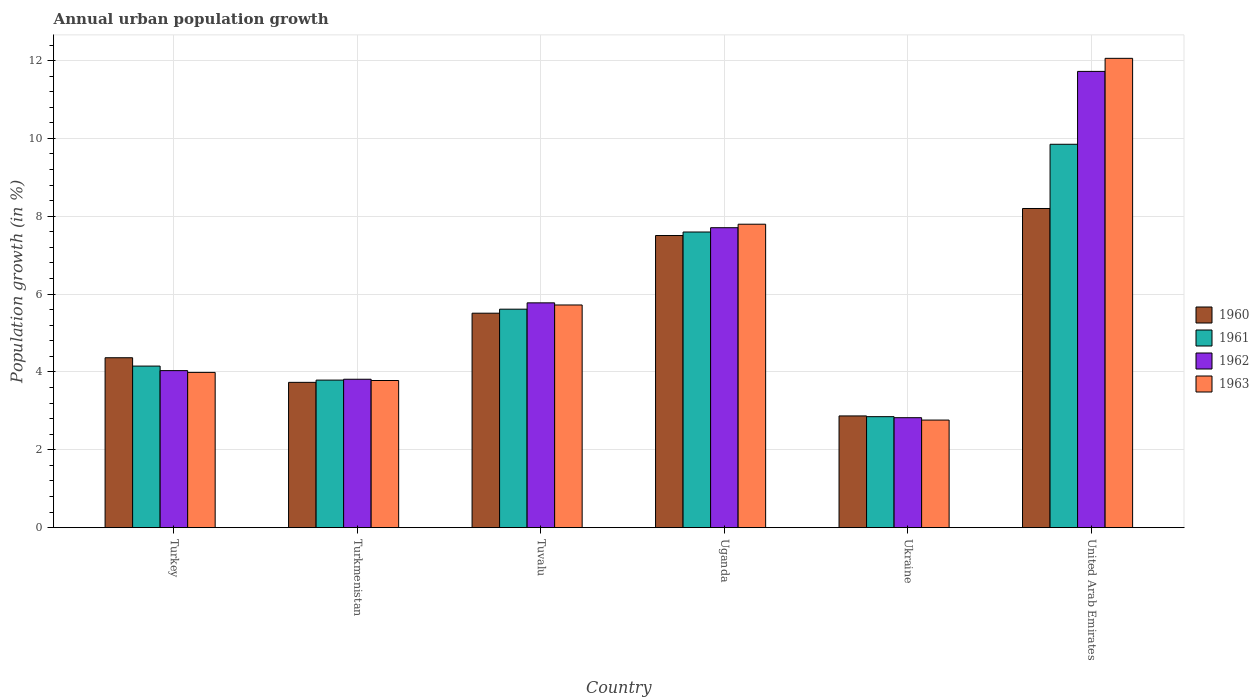How many different coloured bars are there?
Your answer should be compact. 4. How many groups of bars are there?
Your answer should be very brief. 6. How many bars are there on the 6th tick from the left?
Keep it short and to the point. 4. How many bars are there on the 3rd tick from the right?
Your answer should be very brief. 4. What is the label of the 2nd group of bars from the left?
Offer a terse response. Turkmenistan. In how many cases, is the number of bars for a given country not equal to the number of legend labels?
Your response must be concise. 0. What is the percentage of urban population growth in 1963 in United Arab Emirates?
Provide a succinct answer. 12.06. Across all countries, what is the maximum percentage of urban population growth in 1963?
Make the answer very short. 12.06. Across all countries, what is the minimum percentage of urban population growth in 1963?
Your answer should be very brief. 2.76. In which country was the percentage of urban population growth in 1961 maximum?
Give a very brief answer. United Arab Emirates. In which country was the percentage of urban population growth in 1961 minimum?
Provide a short and direct response. Ukraine. What is the total percentage of urban population growth in 1960 in the graph?
Your answer should be compact. 32.18. What is the difference between the percentage of urban population growth in 1961 in Turkey and that in Ukraine?
Offer a terse response. 1.3. What is the difference between the percentage of urban population growth in 1961 in Turkmenistan and the percentage of urban population growth in 1962 in Turkey?
Keep it short and to the point. -0.24. What is the average percentage of urban population growth in 1961 per country?
Your answer should be compact. 5.64. What is the difference between the percentage of urban population growth of/in 1960 and percentage of urban population growth of/in 1961 in Tuvalu?
Your response must be concise. -0.1. What is the ratio of the percentage of urban population growth in 1960 in Tuvalu to that in Uganda?
Offer a terse response. 0.73. Is the percentage of urban population growth in 1962 in Turkey less than that in Tuvalu?
Your response must be concise. Yes. Is the difference between the percentage of urban population growth in 1960 in Turkmenistan and Uganda greater than the difference between the percentage of urban population growth in 1961 in Turkmenistan and Uganda?
Offer a terse response. Yes. What is the difference between the highest and the second highest percentage of urban population growth in 1960?
Give a very brief answer. 2.69. What is the difference between the highest and the lowest percentage of urban population growth in 1961?
Your response must be concise. 7. Is it the case that in every country, the sum of the percentage of urban population growth in 1961 and percentage of urban population growth in 1963 is greater than the sum of percentage of urban population growth in 1960 and percentage of urban population growth in 1962?
Offer a very short reply. No. What does the 1st bar from the right in Turkmenistan represents?
Keep it short and to the point. 1963. How many bars are there?
Your answer should be compact. 24. Are all the bars in the graph horizontal?
Give a very brief answer. No. What is the title of the graph?
Offer a very short reply. Annual urban population growth. Does "1998" appear as one of the legend labels in the graph?
Provide a short and direct response. No. What is the label or title of the Y-axis?
Ensure brevity in your answer.  Population growth (in %). What is the Population growth (in %) of 1960 in Turkey?
Give a very brief answer. 4.37. What is the Population growth (in %) of 1961 in Turkey?
Provide a short and direct response. 4.15. What is the Population growth (in %) of 1962 in Turkey?
Offer a very short reply. 4.03. What is the Population growth (in %) in 1963 in Turkey?
Provide a succinct answer. 3.99. What is the Population growth (in %) of 1960 in Turkmenistan?
Provide a short and direct response. 3.73. What is the Population growth (in %) in 1961 in Turkmenistan?
Keep it short and to the point. 3.79. What is the Population growth (in %) in 1962 in Turkmenistan?
Offer a terse response. 3.81. What is the Population growth (in %) in 1963 in Turkmenistan?
Offer a very short reply. 3.78. What is the Population growth (in %) in 1960 in Tuvalu?
Give a very brief answer. 5.51. What is the Population growth (in %) in 1961 in Tuvalu?
Your answer should be compact. 5.61. What is the Population growth (in %) of 1962 in Tuvalu?
Offer a very short reply. 5.78. What is the Population growth (in %) of 1963 in Tuvalu?
Make the answer very short. 5.72. What is the Population growth (in %) in 1960 in Uganda?
Keep it short and to the point. 7.51. What is the Population growth (in %) in 1961 in Uganda?
Provide a succinct answer. 7.6. What is the Population growth (in %) in 1962 in Uganda?
Ensure brevity in your answer.  7.71. What is the Population growth (in %) of 1963 in Uganda?
Offer a terse response. 7.8. What is the Population growth (in %) of 1960 in Ukraine?
Keep it short and to the point. 2.87. What is the Population growth (in %) in 1961 in Ukraine?
Keep it short and to the point. 2.85. What is the Population growth (in %) of 1962 in Ukraine?
Offer a very short reply. 2.82. What is the Population growth (in %) in 1963 in Ukraine?
Make the answer very short. 2.76. What is the Population growth (in %) in 1960 in United Arab Emirates?
Provide a short and direct response. 8.2. What is the Population growth (in %) in 1961 in United Arab Emirates?
Ensure brevity in your answer.  9.85. What is the Population growth (in %) of 1962 in United Arab Emirates?
Offer a very short reply. 11.72. What is the Population growth (in %) of 1963 in United Arab Emirates?
Your response must be concise. 12.06. Across all countries, what is the maximum Population growth (in %) of 1960?
Your answer should be very brief. 8.2. Across all countries, what is the maximum Population growth (in %) in 1961?
Your answer should be very brief. 9.85. Across all countries, what is the maximum Population growth (in %) in 1962?
Keep it short and to the point. 11.72. Across all countries, what is the maximum Population growth (in %) in 1963?
Provide a succinct answer. 12.06. Across all countries, what is the minimum Population growth (in %) in 1960?
Your answer should be very brief. 2.87. Across all countries, what is the minimum Population growth (in %) of 1961?
Offer a terse response. 2.85. Across all countries, what is the minimum Population growth (in %) in 1962?
Your response must be concise. 2.82. Across all countries, what is the minimum Population growth (in %) of 1963?
Provide a succinct answer. 2.76. What is the total Population growth (in %) in 1960 in the graph?
Offer a very short reply. 32.18. What is the total Population growth (in %) of 1961 in the graph?
Give a very brief answer. 33.85. What is the total Population growth (in %) of 1962 in the graph?
Give a very brief answer. 35.88. What is the total Population growth (in %) in 1963 in the graph?
Provide a succinct answer. 36.11. What is the difference between the Population growth (in %) in 1960 in Turkey and that in Turkmenistan?
Offer a very short reply. 0.63. What is the difference between the Population growth (in %) of 1961 in Turkey and that in Turkmenistan?
Provide a succinct answer. 0.36. What is the difference between the Population growth (in %) of 1962 in Turkey and that in Turkmenistan?
Your answer should be compact. 0.22. What is the difference between the Population growth (in %) of 1963 in Turkey and that in Turkmenistan?
Provide a short and direct response. 0.21. What is the difference between the Population growth (in %) in 1960 in Turkey and that in Tuvalu?
Your answer should be compact. -1.14. What is the difference between the Population growth (in %) of 1961 in Turkey and that in Tuvalu?
Your answer should be very brief. -1.46. What is the difference between the Population growth (in %) of 1962 in Turkey and that in Tuvalu?
Give a very brief answer. -1.74. What is the difference between the Population growth (in %) in 1963 in Turkey and that in Tuvalu?
Give a very brief answer. -1.73. What is the difference between the Population growth (in %) of 1960 in Turkey and that in Uganda?
Give a very brief answer. -3.14. What is the difference between the Population growth (in %) in 1961 in Turkey and that in Uganda?
Give a very brief answer. -3.44. What is the difference between the Population growth (in %) of 1962 in Turkey and that in Uganda?
Make the answer very short. -3.67. What is the difference between the Population growth (in %) of 1963 in Turkey and that in Uganda?
Your response must be concise. -3.81. What is the difference between the Population growth (in %) of 1960 in Turkey and that in Ukraine?
Keep it short and to the point. 1.49. What is the difference between the Population growth (in %) in 1961 in Turkey and that in Ukraine?
Ensure brevity in your answer.  1.3. What is the difference between the Population growth (in %) of 1962 in Turkey and that in Ukraine?
Your answer should be very brief. 1.21. What is the difference between the Population growth (in %) of 1963 in Turkey and that in Ukraine?
Offer a terse response. 1.22. What is the difference between the Population growth (in %) of 1960 in Turkey and that in United Arab Emirates?
Give a very brief answer. -3.83. What is the difference between the Population growth (in %) in 1961 in Turkey and that in United Arab Emirates?
Your answer should be compact. -5.7. What is the difference between the Population growth (in %) in 1962 in Turkey and that in United Arab Emirates?
Your answer should be compact. -7.69. What is the difference between the Population growth (in %) of 1963 in Turkey and that in United Arab Emirates?
Offer a very short reply. -8.07. What is the difference between the Population growth (in %) of 1960 in Turkmenistan and that in Tuvalu?
Provide a succinct answer. -1.78. What is the difference between the Population growth (in %) in 1961 in Turkmenistan and that in Tuvalu?
Keep it short and to the point. -1.82. What is the difference between the Population growth (in %) in 1962 in Turkmenistan and that in Tuvalu?
Provide a short and direct response. -1.96. What is the difference between the Population growth (in %) in 1963 in Turkmenistan and that in Tuvalu?
Ensure brevity in your answer.  -1.94. What is the difference between the Population growth (in %) of 1960 in Turkmenistan and that in Uganda?
Provide a short and direct response. -3.77. What is the difference between the Population growth (in %) of 1961 in Turkmenistan and that in Uganda?
Offer a terse response. -3.8. What is the difference between the Population growth (in %) of 1962 in Turkmenistan and that in Uganda?
Offer a very short reply. -3.89. What is the difference between the Population growth (in %) in 1963 in Turkmenistan and that in Uganda?
Make the answer very short. -4.02. What is the difference between the Population growth (in %) in 1960 in Turkmenistan and that in Ukraine?
Keep it short and to the point. 0.86. What is the difference between the Population growth (in %) of 1961 in Turkmenistan and that in Ukraine?
Provide a succinct answer. 0.94. What is the difference between the Population growth (in %) of 1963 in Turkmenistan and that in Ukraine?
Keep it short and to the point. 1.02. What is the difference between the Population growth (in %) in 1960 in Turkmenistan and that in United Arab Emirates?
Your response must be concise. -4.47. What is the difference between the Population growth (in %) in 1961 in Turkmenistan and that in United Arab Emirates?
Keep it short and to the point. -6.06. What is the difference between the Population growth (in %) of 1962 in Turkmenistan and that in United Arab Emirates?
Offer a terse response. -7.91. What is the difference between the Population growth (in %) of 1963 in Turkmenistan and that in United Arab Emirates?
Ensure brevity in your answer.  -8.28. What is the difference between the Population growth (in %) in 1960 in Tuvalu and that in Uganda?
Your answer should be very brief. -2. What is the difference between the Population growth (in %) in 1961 in Tuvalu and that in Uganda?
Provide a succinct answer. -1.98. What is the difference between the Population growth (in %) in 1962 in Tuvalu and that in Uganda?
Provide a short and direct response. -1.93. What is the difference between the Population growth (in %) in 1963 in Tuvalu and that in Uganda?
Give a very brief answer. -2.08. What is the difference between the Population growth (in %) of 1960 in Tuvalu and that in Ukraine?
Ensure brevity in your answer.  2.64. What is the difference between the Population growth (in %) in 1961 in Tuvalu and that in Ukraine?
Ensure brevity in your answer.  2.76. What is the difference between the Population growth (in %) in 1962 in Tuvalu and that in Ukraine?
Ensure brevity in your answer.  2.95. What is the difference between the Population growth (in %) in 1963 in Tuvalu and that in Ukraine?
Make the answer very short. 2.96. What is the difference between the Population growth (in %) of 1960 in Tuvalu and that in United Arab Emirates?
Your answer should be very brief. -2.69. What is the difference between the Population growth (in %) in 1961 in Tuvalu and that in United Arab Emirates?
Provide a short and direct response. -4.24. What is the difference between the Population growth (in %) in 1962 in Tuvalu and that in United Arab Emirates?
Provide a short and direct response. -5.95. What is the difference between the Population growth (in %) of 1963 in Tuvalu and that in United Arab Emirates?
Keep it short and to the point. -6.34. What is the difference between the Population growth (in %) of 1960 in Uganda and that in Ukraine?
Offer a very short reply. 4.64. What is the difference between the Population growth (in %) of 1961 in Uganda and that in Ukraine?
Provide a succinct answer. 4.74. What is the difference between the Population growth (in %) of 1962 in Uganda and that in Ukraine?
Offer a very short reply. 4.88. What is the difference between the Population growth (in %) of 1963 in Uganda and that in Ukraine?
Your response must be concise. 5.03. What is the difference between the Population growth (in %) in 1960 in Uganda and that in United Arab Emirates?
Your response must be concise. -0.69. What is the difference between the Population growth (in %) in 1961 in Uganda and that in United Arab Emirates?
Offer a very short reply. -2.25. What is the difference between the Population growth (in %) in 1962 in Uganda and that in United Arab Emirates?
Provide a short and direct response. -4.02. What is the difference between the Population growth (in %) in 1963 in Uganda and that in United Arab Emirates?
Give a very brief answer. -4.26. What is the difference between the Population growth (in %) of 1960 in Ukraine and that in United Arab Emirates?
Provide a short and direct response. -5.33. What is the difference between the Population growth (in %) of 1961 in Ukraine and that in United Arab Emirates?
Provide a short and direct response. -7. What is the difference between the Population growth (in %) in 1962 in Ukraine and that in United Arab Emirates?
Provide a succinct answer. -8.9. What is the difference between the Population growth (in %) in 1963 in Ukraine and that in United Arab Emirates?
Provide a succinct answer. -9.29. What is the difference between the Population growth (in %) in 1960 in Turkey and the Population growth (in %) in 1961 in Turkmenistan?
Keep it short and to the point. 0.57. What is the difference between the Population growth (in %) of 1960 in Turkey and the Population growth (in %) of 1962 in Turkmenistan?
Give a very brief answer. 0.55. What is the difference between the Population growth (in %) in 1960 in Turkey and the Population growth (in %) in 1963 in Turkmenistan?
Ensure brevity in your answer.  0.58. What is the difference between the Population growth (in %) of 1961 in Turkey and the Population growth (in %) of 1962 in Turkmenistan?
Give a very brief answer. 0.34. What is the difference between the Population growth (in %) in 1961 in Turkey and the Population growth (in %) in 1963 in Turkmenistan?
Provide a succinct answer. 0.37. What is the difference between the Population growth (in %) of 1962 in Turkey and the Population growth (in %) of 1963 in Turkmenistan?
Give a very brief answer. 0.25. What is the difference between the Population growth (in %) in 1960 in Turkey and the Population growth (in %) in 1961 in Tuvalu?
Make the answer very short. -1.25. What is the difference between the Population growth (in %) in 1960 in Turkey and the Population growth (in %) in 1962 in Tuvalu?
Provide a succinct answer. -1.41. What is the difference between the Population growth (in %) of 1960 in Turkey and the Population growth (in %) of 1963 in Tuvalu?
Provide a succinct answer. -1.36. What is the difference between the Population growth (in %) in 1961 in Turkey and the Population growth (in %) in 1962 in Tuvalu?
Your answer should be compact. -1.62. What is the difference between the Population growth (in %) of 1961 in Turkey and the Population growth (in %) of 1963 in Tuvalu?
Offer a terse response. -1.57. What is the difference between the Population growth (in %) of 1962 in Turkey and the Population growth (in %) of 1963 in Tuvalu?
Offer a very short reply. -1.69. What is the difference between the Population growth (in %) in 1960 in Turkey and the Population growth (in %) in 1961 in Uganda?
Offer a very short reply. -3.23. What is the difference between the Population growth (in %) in 1960 in Turkey and the Population growth (in %) in 1962 in Uganda?
Give a very brief answer. -3.34. What is the difference between the Population growth (in %) in 1960 in Turkey and the Population growth (in %) in 1963 in Uganda?
Your answer should be compact. -3.43. What is the difference between the Population growth (in %) of 1961 in Turkey and the Population growth (in %) of 1962 in Uganda?
Make the answer very short. -3.56. What is the difference between the Population growth (in %) of 1961 in Turkey and the Population growth (in %) of 1963 in Uganda?
Your answer should be compact. -3.65. What is the difference between the Population growth (in %) of 1962 in Turkey and the Population growth (in %) of 1963 in Uganda?
Provide a short and direct response. -3.76. What is the difference between the Population growth (in %) of 1960 in Turkey and the Population growth (in %) of 1961 in Ukraine?
Ensure brevity in your answer.  1.51. What is the difference between the Population growth (in %) of 1960 in Turkey and the Population growth (in %) of 1962 in Ukraine?
Your answer should be compact. 1.54. What is the difference between the Population growth (in %) in 1960 in Turkey and the Population growth (in %) in 1963 in Ukraine?
Make the answer very short. 1.6. What is the difference between the Population growth (in %) in 1961 in Turkey and the Population growth (in %) in 1962 in Ukraine?
Provide a succinct answer. 1.33. What is the difference between the Population growth (in %) of 1961 in Turkey and the Population growth (in %) of 1963 in Ukraine?
Provide a short and direct response. 1.39. What is the difference between the Population growth (in %) in 1962 in Turkey and the Population growth (in %) in 1963 in Ukraine?
Offer a terse response. 1.27. What is the difference between the Population growth (in %) in 1960 in Turkey and the Population growth (in %) in 1961 in United Arab Emirates?
Your answer should be very brief. -5.48. What is the difference between the Population growth (in %) in 1960 in Turkey and the Population growth (in %) in 1962 in United Arab Emirates?
Your answer should be very brief. -7.36. What is the difference between the Population growth (in %) in 1960 in Turkey and the Population growth (in %) in 1963 in United Arab Emirates?
Your response must be concise. -7.69. What is the difference between the Population growth (in %) of 1961 in Turkey and the Population growth (in %) of 1962 in United Arab Emirates?
Keep it short and to the point. -7.57. What is the difference between the Population growth (in %) in 1961 in Turkey and the Population growth (in %) in 1963 in United Arab Emirates?
Give a very brief answer. -7.91. What is the difference between the Population growth (in %) in 1962 in Turkey and the Population growth (in %) in 1963 in United Arab Emirates?
Keep it short and to the point. -8.02. What is the difference between the Population growth (in %) in 1960 in Turkmenistan and the Population growth (in %) in 1961 in Tuvalu?
Your response must be concise. -1.88. What is the difference between the Population growth (in %) of 1960 in Turkmenistan and the Population growth (in %) of 1962 in Tuvalu?
Make the answer very short. -2.04. What is the difference between the Population growth (in %) in 1960 in Turkmenistan and the Population growth (in %) in 1963 in Tuvalu?
Provide a succinct answer. -1.99. What is the difference between the Population growth (in %) in 1961 in Turkmenistan and the Population growth (in %) in 1962 in Tuvalu?
Your answer should be compact. -1.98. What is the difference between the Population growth (in %) of 1961 in Turkmenistan and the Population growth (in %) of 1963 in Tuvalu?
Offer a terse response. -1.93. What is the difference between the Population growth (in %) in 1962 in Turkmenistan and the Population growth (in %) in 1963 in Tuvalu?
Offer a very short reply. -1.91. What is the difference between the Population growth (in %) of 1960 in Turkmenistan and the Population growth (in %) of 1961 in Uganda?
Keep it short and to the point. -3.86. What is the difference between the Population growth (in %) in 1960 in Turkmenistan and the Population growth (in %) in 1962 in Uganda?
Provide a short and direct response. -3.97. What is the difference between the Population growth (in %) of 1960 in Turkmenistan and the Population growth (in %) of 1963 in Uganda?
Ensure brevity in your answer.  -4.06. What is the difference between the Population growth (in %) of 1961 in Turkmenistan and the Population growth (in %) of 1962 in Uganda?
Your answer should be very brief. -3.92. What is the difference between the Population growth (in %) in 1961 in Turkmenistan and the Population growth (in %) in 1963 in Uganda?
Provide a succinct answer. -4.01. What is the difference between the Population growth (in %) in 1962 in Turkmenistan and the Population growth (in %) in 1963 in Uganda?
Your answer should be very brief. -3.98. What is the difference between the Population growth (in %) of 1960 in Turkmenistan and the Population growth (in %) of 1961 in Ukraine?
Offer a terse response. 0.88. What is the difference between the Population growth (in %) in 1960 in Turkmenistan and the Population growth (in %) in 1962 in Ukraine?
Offer a terse response. 0.91. What is the difference between the Population growth (in %) of 1960 in Turkmenistan and the Population growth (in %) of 1963 in Ukraine?
Provide a succinct answer. 0.97. What is the difference between the Population growth (in %) of 1961 in Turkmenistan and the Population growth (in %) of 1962 in Ukraine?
Keep it short and to the point. 0.97. What is the difference between the Population growth (in %) in 1962 in Turkmenistan and the Population growth (in %) in 1963 in Ukraine?
Offer a terse response. 1.05. What is the difference between the Population growth (in %) in 1960 in Turkmenistan and the Population growth (in %) in 1961 in United Arab Emirates?
Ensure brevity in your answer.  -6.12. What is the difference between the Population growth (in %) in 1960 in Turkmenistan and the Population growth (in %) in 1962 in United Arab Emirates?
Offer a very short reply. -7.99. What is the difference between the Population growth (in %) in 1960 in Turkmenistan and the Population growth (in %) in 1963 in United Arab Emirates?
Your response must be concise. -8.32. What is the difference between the Population growth (in %) of 1961 in Turkmenistan and the Population growth (in %) of 1962 in United Arab Emirates?
Offer a terse response. -7.93. What is the difference between the Population growth (in %) of 1961 in Turkmenistan and the Population growth (in %) of 1963 in United Arab Emirates?
Your answer should be compact. -8.27. What is the difference between the Population growth (in %) of 1962 in Turkmenistan and the Population growth (in %) of 1963 in United Arab Emirates?
Your answer should be compact. -8.24. What is the difference between the Population growth (in %) in 1960 in Tuvalu and the Population growth (in %) in 1961 in Uganda?
Keep it short and to the point. -2.09. What is the difference between the Population growth (in %) of 1960 in Tuvalu and the Population growth (in %) of 1962 in Uganda?
Your answer should be compact. -2.2. What is the difference between the Population growth (in %) of 1960 in Tuvalu and the Population growth (in %) of 1963 in Uganda?
Your answer should be very brief. -2.29. What is the difference between the Population growth (in %) of 1961 in Tuvalu and the Population growth (in %) of 1962 in Uganda?
Keep it short and to the point. -2.09. What is the difference between the Population growth (in %) of 1961 in Tuvalu and the Population growth (in %) of 1963 in Uganda?
Provide a succinct answer. -2.18. What is the difference between the Population growth (in %) of 1962 in Tuvalu and the Population growth (in %) of 1963 in Uganda?
Offer a terse response. -2.02. What is the difference between the Population growth (in %) of 1960 in Tuvalu and the Population growth (in %) of 1961 in Ukraine?
Provide a short and direct response. 2.66. What is the difference between the Population growth (in %) in 1960 in Tuvalu and the Population growth (in %) in 1962 in Ukraine?
Provide a short and direct response. 2.69. What is the difference between the Population growth (in %) of 1960 in Tuvalu and the Population growth (in %) of 1963 in Ukraine?
Your response must be concise. 2.75. What is the difference between the Population growth (in %) in 1961 in Tuvalu and the Population growth (in %) in 1962 in Ukraine?
Give a very brief answer. 2.79. What is the difference between the Population growth (in %) in 1961 in Tuvalu and the Population growth (in %) in 1963 in Ukraine?
Provide a short and direct response. 2.85. What is the difference between the Population growth (in %) in 1962 in Tuvalu and the Population growth (in %) in 1963 in Ukraine?
Ensure brevity in your answer.  3.01. What is the difference between the Population growth (in %) in 1960 in Tuvalu and the Population growth (in %) in 1961 in United Arab Emirates?
Make the answer very short. -4.34. What is the difference between the Population growth (in %) of 1960 in Tuvalu and the Population growth (in %) of 1962 in United Arab Emirates?
Keep it short and to the point. -6.21. What is the difference between the Population growth (in %) of 1960 in Tuvalu and the Population growth (in %) of 1963 in United Arab Emirates?
Your response must be concise. -6.55. What is the difference between the Population growth (in %) of 1961 in Tuvalu and the Population growth (in %) of 1962 in United Arab Emirates?
Provide a short and direct response. -6.11. What is the difference between the Population growth (in %) of 1961 in Tuvalu and the Population growth (in %) of 1963 in United Arab Emirates?
Offer a very short reply. -6.44. What is the difference between the Population growth (in %) of 1962 in Tuvalu and the Population growth (in %) of 1963 in United Arab Emirates?
Your response must be concise. -6.28. What is the difference between the Population growth (in %) of 1960 in Uganda and the Population growth (in %) of 1961 in Ukraine?
Ensure brevity in your answer.  4.65. What is the difference between the Population growth (in %) in 1960 in Uganda and the Population growth (in %) in 1962 in Ukraine?
Give a very brief answer. 4.68. What is the difference between the Population growth (in %) of 1960 in Uganda and the Population growth (in %) of 1963 in Ukraine?
Make the answer very short. 4.74. What is the difference between the Population growth (in %) in 1961 in Uganda and the Population growth (in %) in 1962 in Ukraine?
Offer a terse response. 4.77. What is the difference between the Population growth (in %) of 1961 in Uganda and the Population growth (in %) of 1963 in Ukraine?
Provide a short and direct response. 4.83. What is the difference between the Population growth (in %) in 1962 in Uganda and the Population growth (in %) in 1963 in Ukraine?
Provide a succinct answer. 4.94. What is the difference between the Population growth (in %) in 1960 in Uganda and the Population growth (in %) in 1961 in United Arab Emirates?
Your response must be concise. -2.34. What is the difference between the Population growth (in %) of 1960 in Uganda and the Population growth (in %) of 1962 in United Arab Emirates?
Your response must be concise. -4.22. What is the difference between the Population growth (in %) in 1960 in Uganda and the Population growth (in %) in 1963 in United Arab Emirates?
Offer a terse response. -4.55. What is the difference between the Population growth (in %) of 1961 in Uganda and the Population growth (in %) of 1962 in United Arab Emirates?
Your answer should be compact. -4.13. What is the difference between the Population growth (in %) of 1961 in Uganda and the Population growth (in %) of 1963 in United Arab Emirates?
Ensure brevity in your answer.  -4.46. What is the difference between the Population growth (in %) in 1962 in Uganda and the Population growth (in %) in 1963 in United Arab Emirates?
Your answer should be compact. -4.35. What is the difference between the Population growth (in %) of 1960 in Ukraine and the Population growth (in %) of 1961 in United Arab Emirates?
Keep it short and to the point. -6.98. What is the difference between the Population growth (in %) of 1960 in Ukraine and the Population growth (in %) of 1962 in United Arab Emirates?
Your answer should be very brief. -8.85. What is the difference between the Population growth (in %) of 1960 in Ukraine and the Population growth (in %) of 1963 in United Arab Emirates?
Give a very brief answer. -9.19. What is the difference between the Population growth (in %) in 1961 in Ukraine and the Population growth (in %) in 1962 in United Arab Emirates?
Your response must be concise. -8.87. What is the difference between the Population growth (in %) of 1961 in Ukraine and the Population growth (in %) of 1963 in United Arab Emirates?
Your answer should be very brief. -9.21. What is the difference between the Population growth (in %) of 1962 in Ukraine and the Population growth (in %) of 1963 in United Arab Emirates?
Your response must be concise. -9.23. What is the average Population growth (in %) in 1960 per country?
Keep it short and to the point. 5.36. What is the average Population growth (in %) in 1961 per country?
Offer a terse response. 5.64. What is the average Population growth (in %) in 1962 per country?
Keep it short and to the point. 5.98. What is the average Population growth (in %) of 1963 per country?
Offer a terse response. 6.02. What is the difference between the Population growth (in %) of 1960 and Population growth (in %) of 1961 in Turkey?
Offer a terse response. 0.21. What is the difference between the Population growth (in %) in 1960 and Population growth (in %) in 1962 in Turkey?
Keep it short and to the point. 0.33. What is the difference between the Population growth (in %) in 1960 and Population growth (in %) in 1963 in Turkey?
Make the answer very short. 0.38. What is the difference between the Population growth (in %) in 1961 and Population growth (in %) in 1962 in Turkey?
Your response must be concise. 0.12. What is the difference between the Population growth (in %) in 1961 and Population growth (in %) in 1963 in Turkey?
Offer a terse response. 0.16. What is the difference between the Population growth (in %) in 1962 and Population growth (in %) in 1963 in Turkey?
Offer a terse response. 0.05. What is the difference between the Population growth (in %) of 1960 and Population growth (in %) of 1961 in Turkmenistan?
Your answer should be very brief. -0.06. What is the difference between the Population growth (in %) in 1960 and Population growth (in %) in 1962 in Turkmenistan?
Your answer should be compact. -0.08. What is the difference between the Population growth (in %) of 1960 and Population growth (in %) of 1963 in Turkmenistan?
Your answer should be compact. -0.05. What is the difference between the Population growth (in %) in 1961 and Population growth (in %) in 1962 in Turkmenistan?
Your answer should be compact. -0.02. What is the difference between the Population growth (in %) in 1961 and Population growth (in %) in 1963 in Turkmenistan?
Keep it short and to the point. 0.01. What is the difference between the Population growth (in %) in 1962 and Population growth (in %) in 1963 in Turkmenistan?
Your answer should be compact. 0.03. What is the difference between the Population growth (in %) of 1960 and Population growth (in %) of 1961 in Tuvalu?
Provide a succinct answer. -0.1. What is the difference between the Population growth (in %) of 1960 and Population growth (in %) of 1962 in Tuvalu?
Offer a very short reply. -0.27. What is the difference between the Population growth (in %) in 1960 and Population growth (in %) in 1963 in Tuvalu?
Provide a short and direct response. -0.21. What is the difference between the Population growth (in %) of 1961 and Population growth (in %) of 1962 in Tuvalu?
Make the answer very short. -0.16. What is the difference between the Population growth (in %) of 1961 and Population growth (in %) of 1963 in Tuvalu?
Ensure brevity in your answer.  -0.11. What is the difference between the Population growth (in %) in 1962 and Population growth (in %) in 1963 in Tuvalu?
Offer a very short reply. 0.05. What is the difference between the Population growth (in %) of 1960 and Population growth (in %) of 1961 in Uganda?
Provide a short and direct response. -0.09. What is the difference between the Population growth (in %) of 1960 and Population growth (in %) of 1962 in Uganda?
Provide a short and direct response. -0.2. What is the difference between the Population growth (in %) of 1960 and Population growth (in %) of 1963 in Uganda?
Your answer should be very brief. -0.29. What is the difference between the Population growth (in %) of 1961 and Population growth (in %) of 1962 in Uganda?
Offer a terse response. -0.11. What is the difference between the Population growth (in %) in 1961 and Population growth (in %) in 1963 in Uganda?
Offer a terse response. -0.2. What is the difference between the Population growth (in %) of 1962 and Population growth (in %) of 1963 in Uganda?
Offer a terse response. -0.09. What is the difference between the Population growth (in %) of 1960 and Population growth (in %) of 1961 in Ukraine?
Provide a succinct answer. 0.02. What is the difference between the Population growth (in %) of 1960 and Population growth (in %) of 1962 in Ukraine?
Keep it short and to the point. 0.05. What is the difference between the Population growth (in %) in 1960 and Population growth (in %) in 1963 in Ukraine?
Offer a terse response. 0.11. What is the difference between the Population growth (in %) of 1961 and Population growth (in %) of 1962 in Ukraine?
Offer a terse response. 0.03. What is the difference between the Population growth (in %) in 1961 and Population growth (in %) in 1963 in Ukraine?
Give a very brief answer. 0.09. What is the difference between the Population growth (in %) in 1962 and Population growth (in %) in 1963 in Ukraine?
Your answer should be very brief. 0.06. What is the difference between the Population growth (in %) of 1960 and Population growth (in %) of 1961 in United Arab Emirates?
Provide a short and direct response. -1.65. What is the difference between the Population growth (in %) of 1960 and Population growth (in %) of 1962 in United Arab Emirates?
Your answer should be very brief. -3.52. What is the difference between the Population growth (in %) in 1960 and Population growth (in %) in 1963 in United Arab Emirates?
Provide a short and direct response. -3.86. What is the difference between the Population growth (in %) in 1961 and Population growth (in %) in 1962 in United Arab Emirates?
Your answer should be very brief. -1.87. What is the difference between the Population growth (in %) of 1961 and Population growth (in %) of 1963 in United Arab Emirates?
Provide a short and direct response. -2.21. What is the difference between the Population growth (in %) in 1962 and Population growth (in %) in 1963 in United Arab Emirates?
Make the answer very short. -0.34. What is the ratio of the Population growth (in %) in 1960 in Turkey to that in Turkmenistan?
Your answer should be very brief. 1.17. What is the ratio of the Population growth (in %) in 1961 in Turkey to that in Turkmenistan?
Keep it short and to the point. 1.09. What is the ratio of the Population growth (in %) of 1962 in Turkey to that in Turkmenistan?
Keep it short and to the point. 1.06. What is the ratio of the Population growth (in %) in 1963 in Turkey to that in Turkmenistan?
Make the answer very short. 1.06. What is the ratio of the Population growth (in %) of 1960 in Turkey to that in Tuvalu?
Your response must be concise. 0.79. What is the ratio of the Population growth (in %) of 1961 in Turkey to that in Tuvalu?
Give a very brief answer. 0.74. What is the ratio of the Population growth (in %) in 1962 in Turkey to that in Tuvalu?
Ensure brevity in your answer.  0.7. What is the ratio of the Population growth (in %) in 1963 in Turkey to that in Tuvalu?
Offer a terse response. 0.7. What is the ratio of the Population growth (in %) in 1960 in Turkey to that in Uganda?
Offer a very short reply. 0.58. What is the ratio of the Population growth (in %) in 1961 in Turkey to that in Uganda?
Your answer should be very brief. 0.55. What is the ratio of the Population growth (in %) of 1962 in Turkey to that in Uganda?
Provide a succinct answer. 0.52. What is the ratio of the Population growth (in %) in 1963 in Turkey to that in Uganda?
Offer a very short reply. 0.51. What is the ratio of the Population growth (in %) in 1960 in Turkey to that in Ukraine?
Your answer should be very brief. 1.52. What is the ratio of the Population growth (in %) of 1961 in Turkey to that in Ukraine?
Offer a terse response. 1.46. What is the ratio of the Population growth (in %) of 1962 in Turkey to that in Ukraine?
Offer a terse response. 1.43. What is the ratio of the Population growth (in %) of 1963 in Turkey to that in Ukraine?
Provide a succinct answer. 1.44. What is the ratio of the Population growth (in %) of 1960 in Turkey to that in United Arab Emirates?
Provide a short and direct response. 0.53. What is the ratio of the Population growth (in %) in 1961 in Turkey to that in United Arab Emirates?
Your answer should be very brief. 0.42. What is the ratio of the Population growth (in %) in 1962 in Turkey to that in United Arab Emirates?
Provide a succinct answer. 0.34. What is the ratio of the Population growth (in %) in 1963 in Turkey to that in United Arab Emirates?
Make the answer very short. 0.33. What is the ratio of the Population growth (in %) in 1960 in Turkmenistan to that in Tuvalu?
Offer a very short reply. 0.68. What is the ratio of the Population growth (in %) of 1961 in Turkmenistan to that in Tuvalu?
Your response must be concise. 0.68. What is the ratio of the Population growth (in %) in 1962 in Turkmenistan to that in Tuvalu?
Your answer should be compact. 0.66. What is the ratio of the Population growth (in %) in 1963 in Turkmenistan to that in Tuvalu?
Your answer should be compact. 0.66. What is the ratio of the Population growth (in %) in 1960 in Turkmenistan to that in Uganda?
Provide a short and direct response. 0.5. What is the ratio of the Population growth (in %) of 1961 in Turkmenistan to that in Uganda?
Keep it short and to the point. 0.5. What is the ratio of the Population growth (in %) in 1962 in Turkmenistan to that in Uganda?
Offer a terse response. 0.49. What is the ratio of the Population growth (in %) in 1963 in Turkmenistan to that in Uganda?
Your response must be concise. 0.48. What is the ratio of the Population growth (in %) of 1960 in Turkmenistan to that in Ukraine?
Offer a very short reply. 1.3. What is the ratio of the Population growth (in %) of 1961 in Turkmenistan to that in Ukraine?
Keep it short and to the point. 1.33. What is the ratio of the Population growth (in %) of 1962 in Turkmenistan to that in Ukraine?
Your answer should be very brief. 1.35. What is the ratio of the Population growth (in %) of 1963 in Turkmenistan to that in Ukraine?
Offer a very short reply. 1.37. What is the ratio of the Population growth (in %) in 1960 in Turkmenistan to that in United Arab Emirates?
Keep it short and to the point. 0.46. What is the ratio of the Population growth (in %) in 1961 in Turkmenistan to that in United Arab Emirates?
Your answer should be very brief. 0.38. What is the ratio of the Population growth (in %) in 1962 in Turkmenistan to that in United Arab Emirates?
Ensure brevity in your answer.  0.33. What is the ratio of the Population growth (in %) in 1963 in Turkmenistan to that in United Arab Emirates?
Offer a terse response. 0.31. What is the ratio of the Population growth (in %) in 1960 in Tuvalu to that in Uganda?
Offer a very short reply. 0.73. What is the ratio of the Population growth (in %) in 1961 in Tuvalu to that in Uganda?
Offer a very short reply. 0.74. What is the ratio of the Population growth (in %) in 1962 in Tuvalu to that in Uganda?
Your answer should be very brief. 0.75. What is the ratio of the Population growth (in %) in 1963 in Tuvalu to that in Uganda?
Offer a very short reply. 0.73. What is the ratio of the Population growth (in %) in 1960 in Tuvalu to that in Ukraine?
Make the answer very short. 1.92. What is the ratio of the Population growth (in %) of 1961 in Tuvalu to that in Ukraine?
Provide a short and direct response. 1.97. What is the ratio of the Population growth (in %) in 1962 in Tuvalu to that in Ukraine?
Keep it short and to the point. 2.04. What is the ratio of the Population growth (in %) in 1963 in Tuvalu to that in Ukraine?
Keep it short and to the point. 2.07. What is the ratio of the Population growth (in %) in 1960 in Tuvalu to that in United Arab Emirates?
Ensure brevity in your answer.  0.67. What is the ratio of the Population growth (in %) in 1961 in Tuvalu to that in United Arab Emirates?
Your answer should be very brief. 0.57. What is the ratio of the Population growth (in %) of 1962 in Tuvalu to that in United Arab Emirates?
Provide a short and direct response. 0.49. What is the ratio of the Population growth (in %) of 1963 in Tuvalu to that in United Arab Emirates?
Your answer should be compact. 0.47. What is the ratio of the Population growth (in %) of 1960 in Uganda to that in Ukraine?
Make the answer very short. 2.61. What is the ratio of the Population growth (in %) in 1961 in Uganda to that in Ukraine?
Offer a terse response. 2.66. What is the ratio of the Population growth (in %) in 1962 in Uganda to that in Ukraine?
Your answer should be very brief. 2.73. What is the ratio of the Population growth (in %) of 1963 in Uganda to that in Ukraine?
Your answer should be very brief. 2.82. What is the ratio of the Population growth (in %) of 1960 in Uganda to that in United Arab Emirates?
Provide a short and direct response. 0.92. What is the ratio of the Population growth (in %) of 1961 in Uganda to that in United Arab Emirates?
Make the answer very short. 0.77. What is the ratio of the Population growth (in %) of 1962 in Uganda to that in United Arab Emirates?
Offer a terse response. 0.66. What is the ratio of the Population growth (in %) in 1963 in Uganda to that in United Arab Emirates?
Your response must be concise. 0.65. What is the ratio of the Population growth (in %) in 1960 in Ukraine to that in United Arab Emirates?
Ensure brevity in your answer.  0.35. What is the ratio of the Population growth (in %) in 1961 in Ukraine to that in United Arab Emirates?
Your answer should be very brief. 0.29. What is the ratio of the Population growth (in %) of 1962 in Ukraine to that in United Arab Emirates?
Your answer should be very brief. 0.24. What is the ratio of the Population growth (in %) in 1963 in Ukraine to that in United Arab Emirates?
Offer a very short reply. 0.23. What is the difference between the highest and the second highest Population growth (in %) in 1960?
Ensure brevity in your answer.  0.69. What is the difference between the highest and the second highest Population growth (in %) in 1961?
Give a very brief answer. 2.25. What is the difference between the highest and the second highest Population growth (in %) of 1962?
Offer a very short reply. 4.02. What is the difference between the highest and the second highest Population growth (in %) of 1963?
Your response must be concise. 4.26. What is the difference between the highest and the lowest Population growth (in %) of 1960?
Offer a terse response. 5.33. What is the difference between the highest and the lowest Population growth (in %) of 1961?
Offer a very short reply. 7. What is the difference between the highest and the lowest Population growth (in %) in 1962?
Your answer should be compact. 8.9. What is the difference between the highest and the lowest Population growth (in %) of 1963?
Give a very brief answer. 9.29. 